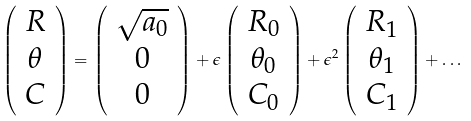Convert formula to latex. <formula><loc_0><loc_0><loc_500><loc_500>\left ( \begin{array} { c c c } R \\ \theta \\ C \end{array} \right ) = \left ( \begin{array} { c c c } \sqrt { a _ { 0 } } \\ 0 \\ 0 \end{array} \right ) + \epsilon \left ( \begin{array} { c c c } R _ { 0 } \\ \theta _ { 0 } \\ C _ { 0 } \end{array} \right ) + \epsilon ^ { 2 } \left ( \begin{array} { c c c } R _ { 1 } \\ \theta _ { 1 } \\ C _ { 1 } \end{array} \right ) + \dots</formula> 